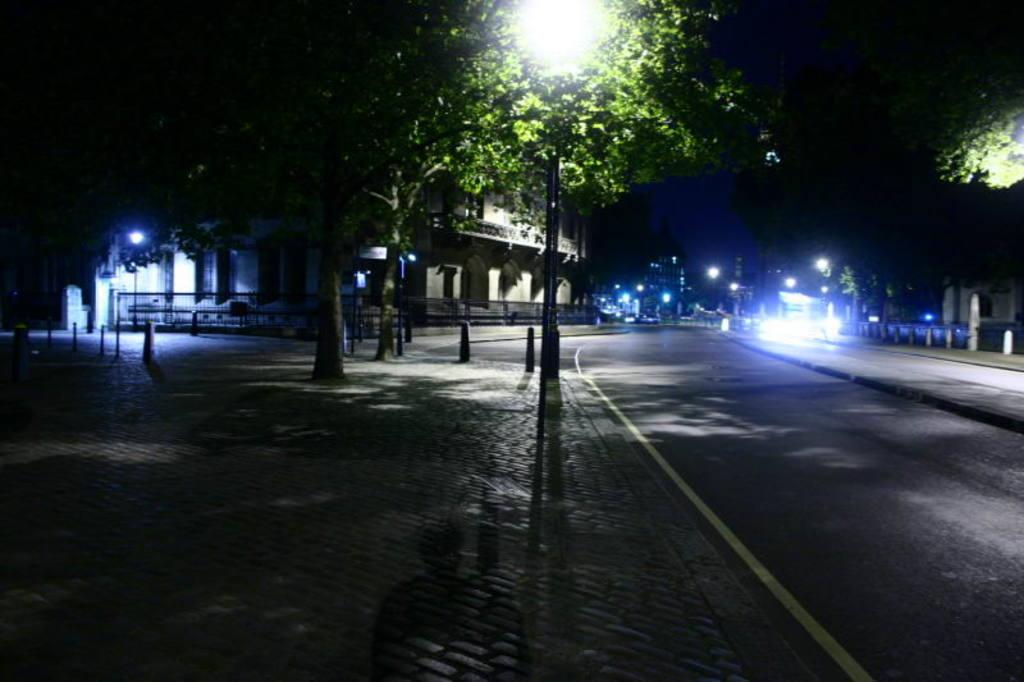What type of structures can be seen in the image? There are buildings in the image. What else is present in the image besides the buildings? There are poles and trees at the top side of the image. Can you describe the time of day when the image was captured? The image appears to be captured during night time. What is the name of the taste that the trees have in the image? Trees do not have tastes, so this question cannot be answered. 